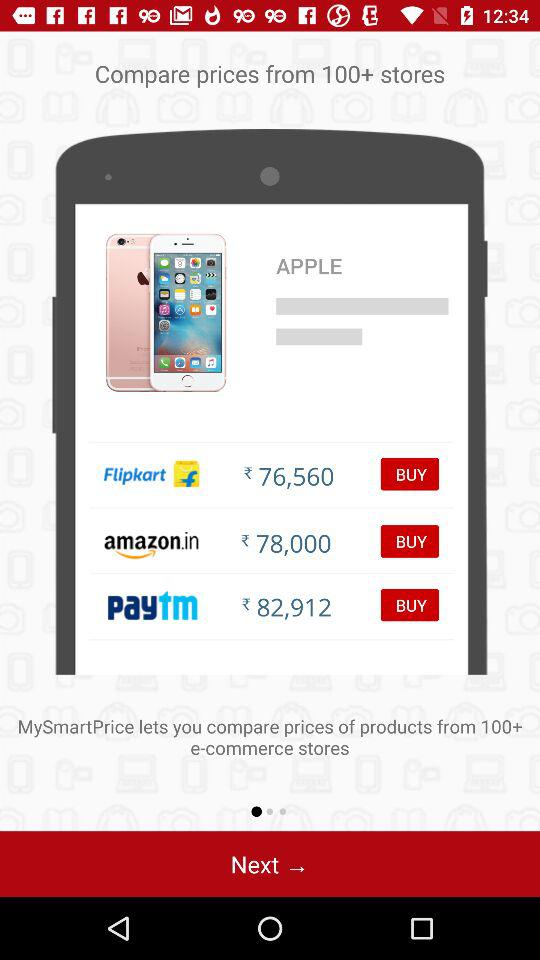Which store has the highest price for the product?
Answer the question using a single word or phrase. Paytm 